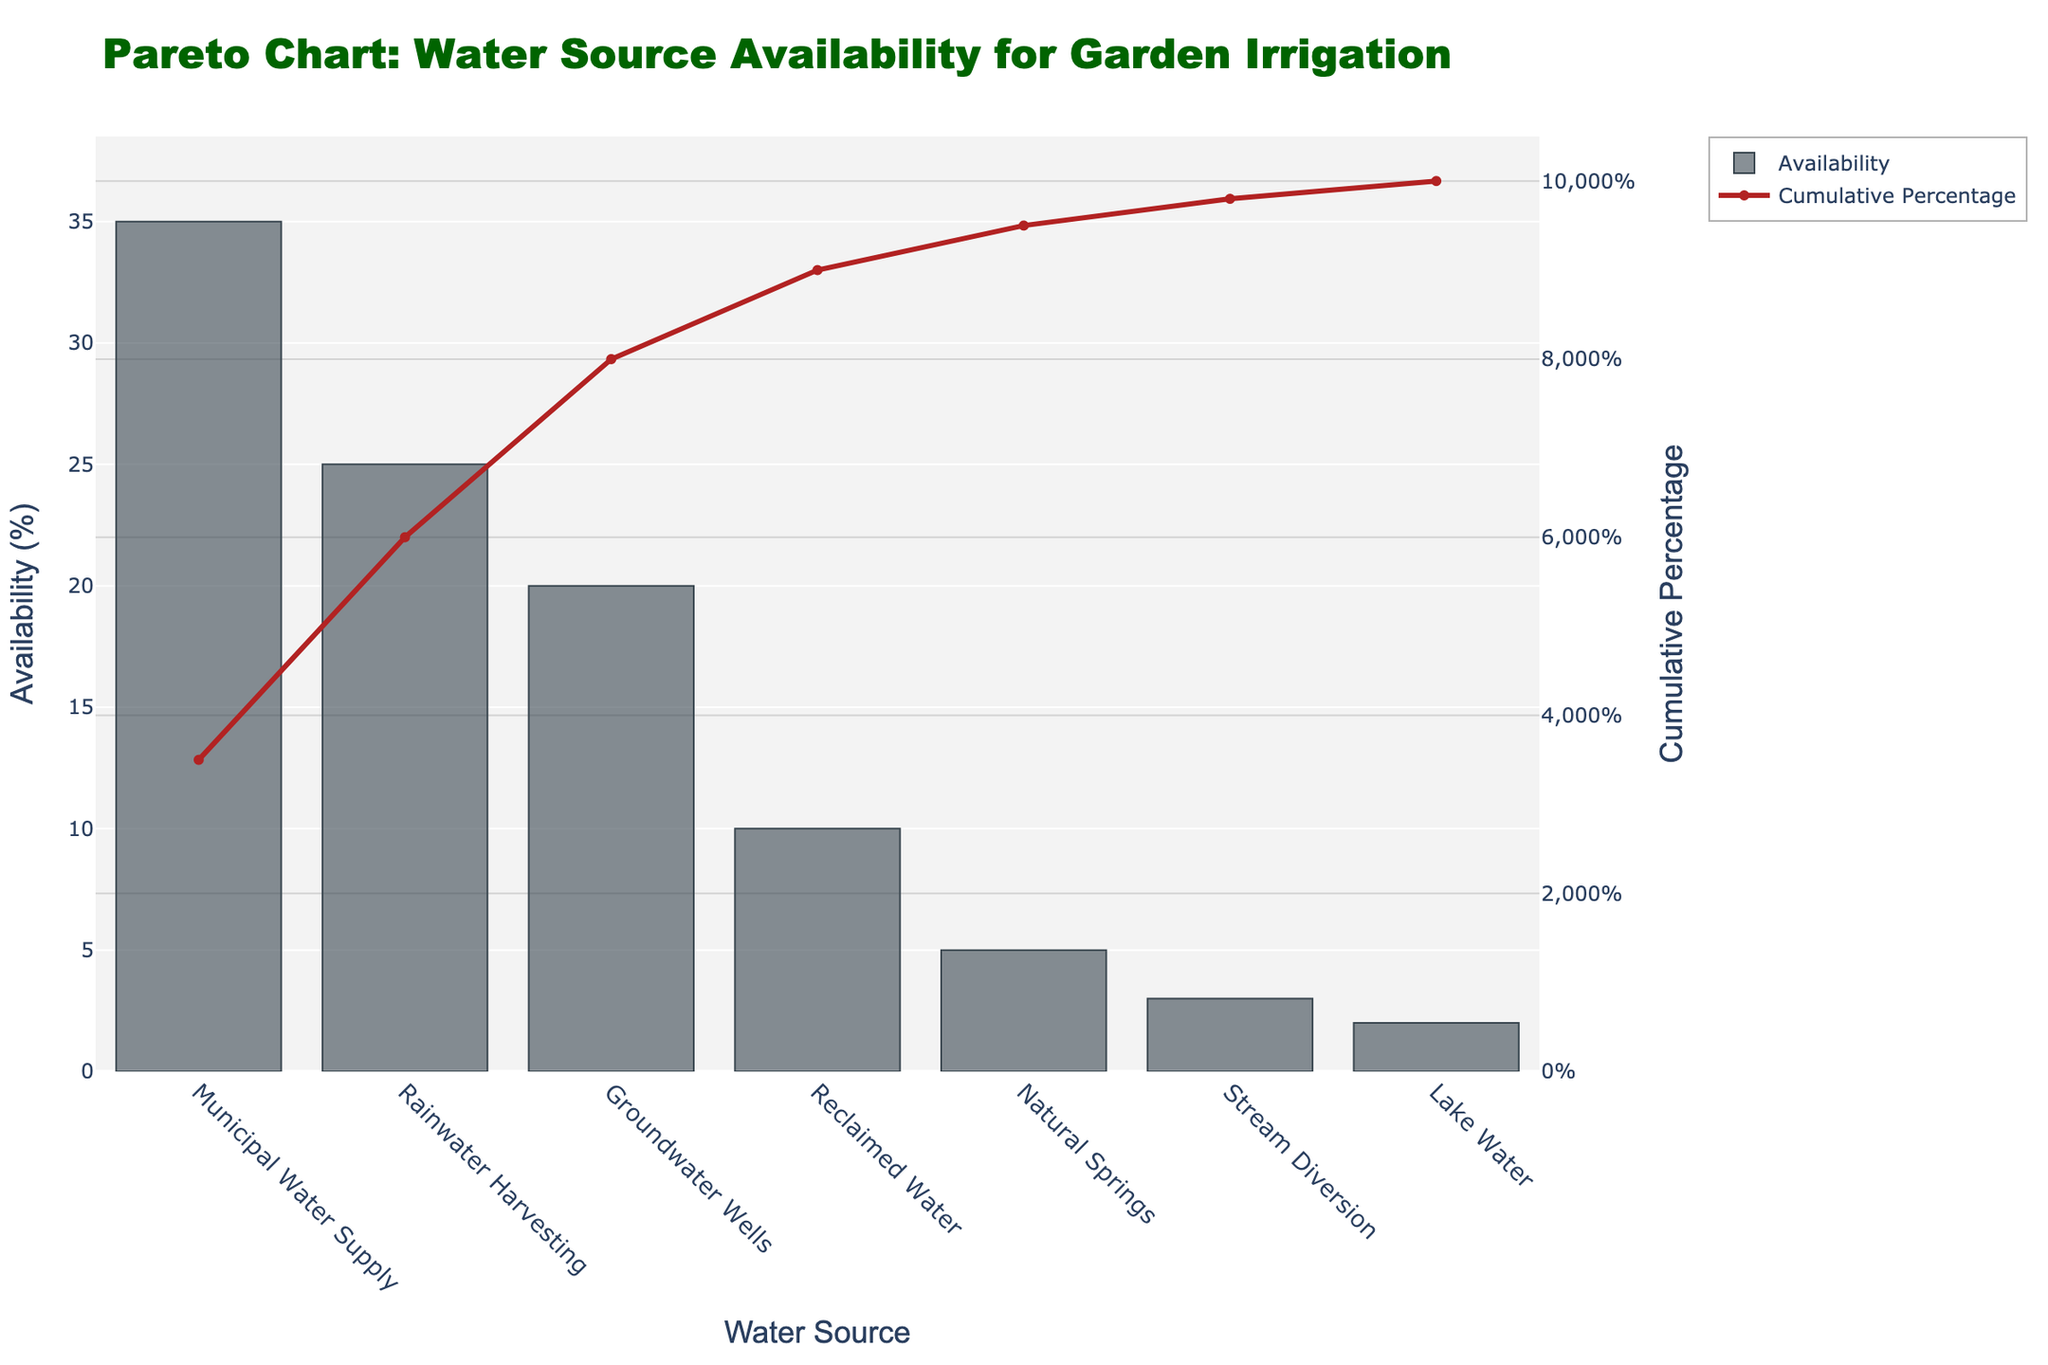What is the most available water source for garden irrigation according to the chart? The chart's bar with the highest height represents the water source with the greatest availability. Municipal Water Supply is clearly the tallest bar in the chart.
Answer: Municipal Water Supply What is the cumulative availability percentage after the second source? To find this, look at the cumulative percentage line. The second source from the left is Rainwater Harvesting. The corresponding cumulative percentage point on the line chart is at 60%.
Answer: 60% Which water sources make up more than 80% of total availability combined? The cumulative percentage line indicates when the percentage surpasses 80%. Municipal Water Supply, Rainwater Harvesting, and Groundwater Wells together exceed 80%, reaching 80% with Groundwater Wells.
Answer: Municipal Water Supply, Rainwater Harvesting, Groundwater Wells How does the availability of Reclaimed Water compare to Groundwater Wells? Compare the heights of the bars for Reclaimed Water and Groundwater Wells. Clearly, the bar for Groundwater Wells is taller (20%) compared to Reclaimed Water (10%).
Answer: Groundwater Wells is higher By how much does Rainwater Harvesting exceed Reclaimed Water in availability percentage? Subtract the availability percentage of Reclaimed Water (10%) from Rainwater Harvesting (25%). This requires simple subtraction: 25% - 10%.
Answer: 15% What percentage of total availability is derived from Municipal Water Supply and Rainwater Harvesting together? Sum the availability percentages of Municipal Water Supply (35%) and Rainwater Harvesting (25%) to get the combined availability. 35% + 25% = 60%.
Answer: 60% Which water source has the least availability and what is its percentage? Identify the shortest bar on the chart, which represents Lake Water, and note its value. The height of the bar indicates 2%.
Answer: Lake Water, 2% What is the cumulative availability percentage up to Natural Springs? Locate the cumulative percentage point corresponding to Natural Springs. The line chart shows that the cumulative percentage is 95% at Natural Springs.
Answer: 95% What is the difference in availability percentage between Stream Diversion and Lake Water? Look at the heights of the bars for Stream Diversion (3%) and Lake Water (2%) and perform the subtraction: 3% - 2%.
Answer: 1% What percentage of the availability does the sum of Stream Diversion and Lake Water contribute? Add the availability percentages of Stream Diversion (3%) and Lake Water (2%). 3% + 2% = 5%.
Answer: 5% 